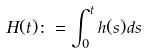<formula> <loc_0><loc_0><loc_500><loc_500>H ( t ) \colon = \int _ { 0 } ^ { t } h ( s ) d s</formula> 